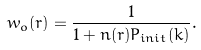<formula> <loc_0><loc_0><loc_500><loc_500>w _ { o } ( r ) = \frac { 1 } { 1 + n ( r ) P _ { i n i t } ( k ) } .</formula> 